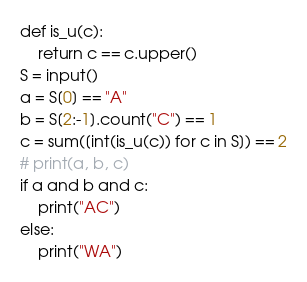<code> <loc_0><loc_0><loc_500><loc_500><_Python_>def is_u(c):
    return c == c.upper()
S = input()
a = S[0] == "A"
b = S[2:-1].count("C") == 1
c = sum([int(is_u(c)) for c in S]) == 2
# print(a, b, c)
if a and b and c:
    print("AC")
else:
    print("WA")</code> 